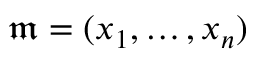<formula> <loc_0><loc_0><loc_500><loc_500>{ \mathfrak { m } } = ( x _ { 1 } , \dots , x _ { n } )</formula> 